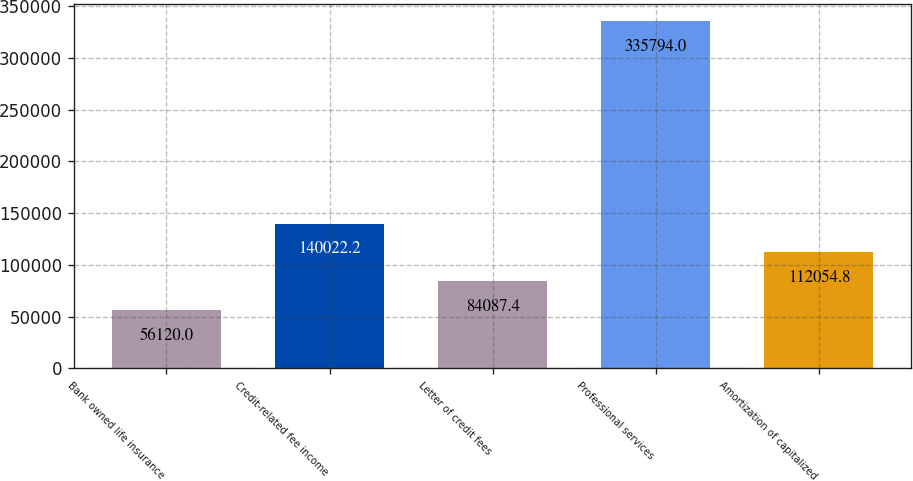Convert chart to OTSL. <chart><loc_0><loc_0><loc_500><loc_500><bar_chart><fcel>Bank owned life insurance<fcel>Credit-related fee income<fcel>Letter of credit fees<fcel>Professional services<fcel>Amortization of capitalized<nl><fcel>56120<fcel>140022<fcel>84087.4<fcel>335794<fcel>112055<nl></chart> 